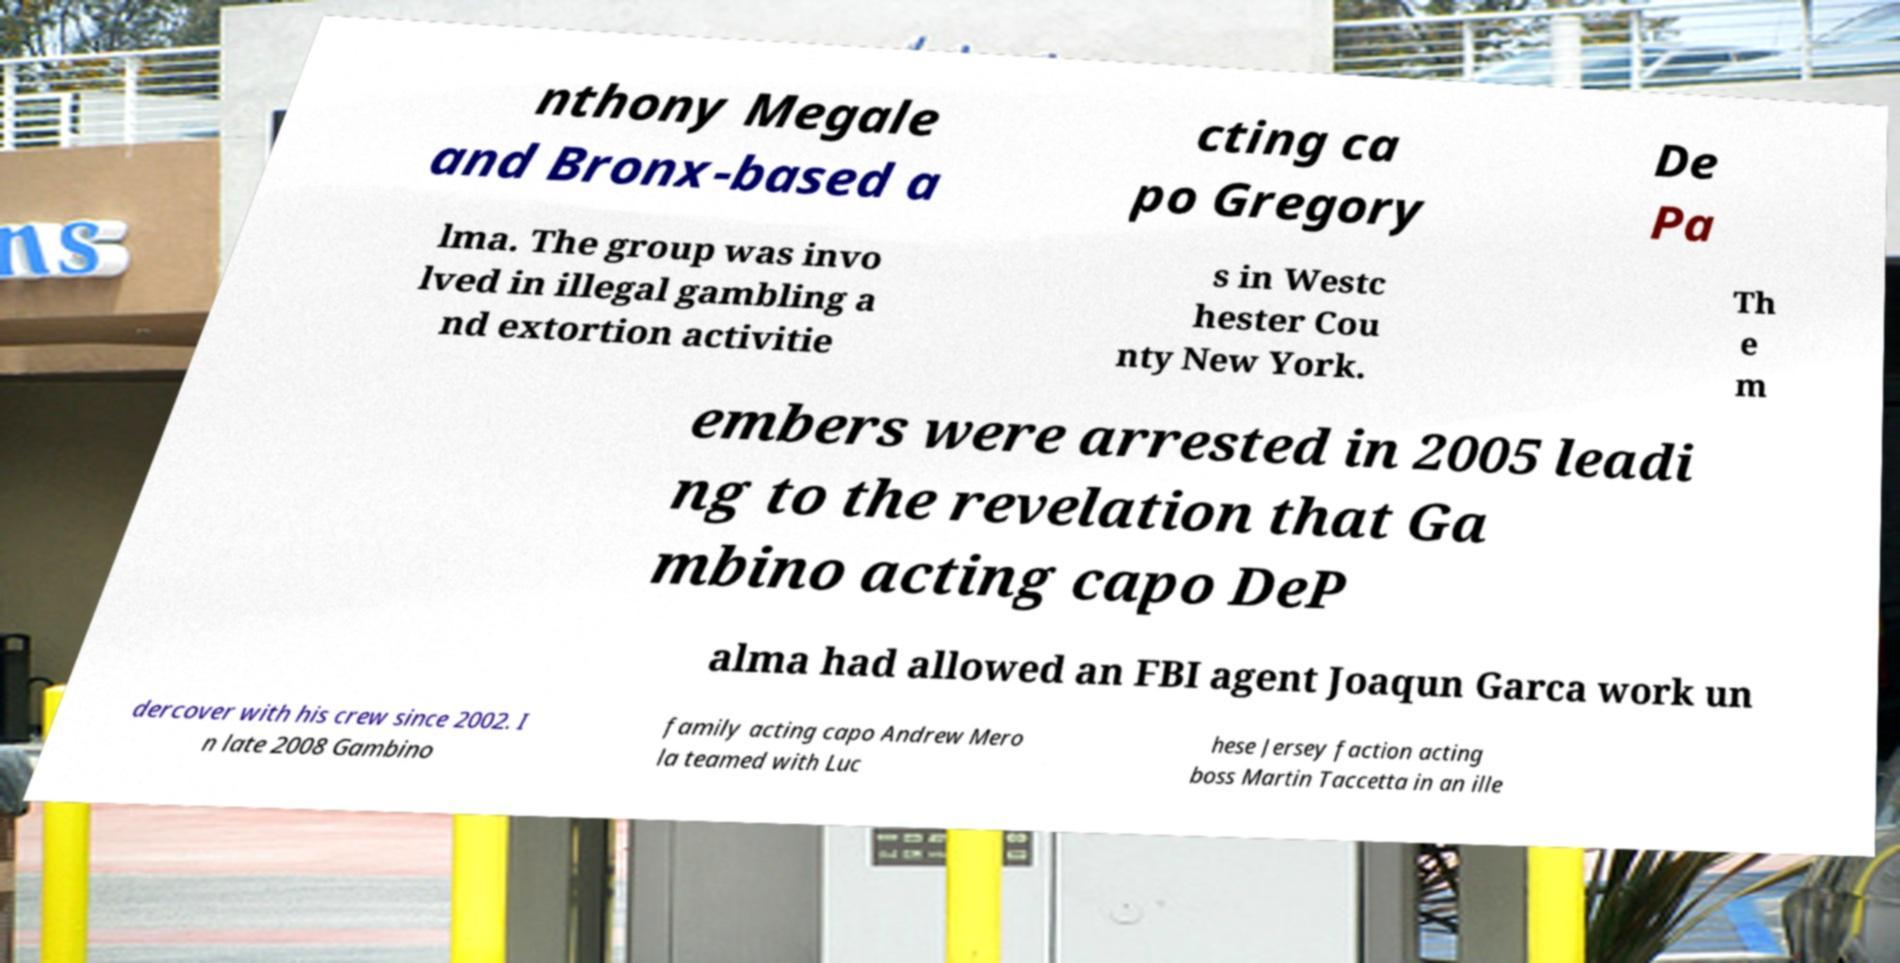For documentation purposes, I need the text within this image transcribed. Could you provide that? nthony Megale and Bronx-based a cting ca po Gregory De Pa lma. The group was invo lved in illegal gambling a nd extortion activitie s in Westc hester Cou nty New York. Th e m embers were arrested in 2005 leadi ng to the revelation that Ga mbino acting capo DeP alma had allowed an FBI agent Joaqun Garca work un dercover with his crew since 2002. I n late 2008 Gambino family acting capo Andrew Mero la teamed with Luc hese Jersey faction acting boss Martin Taccetta in an ille 